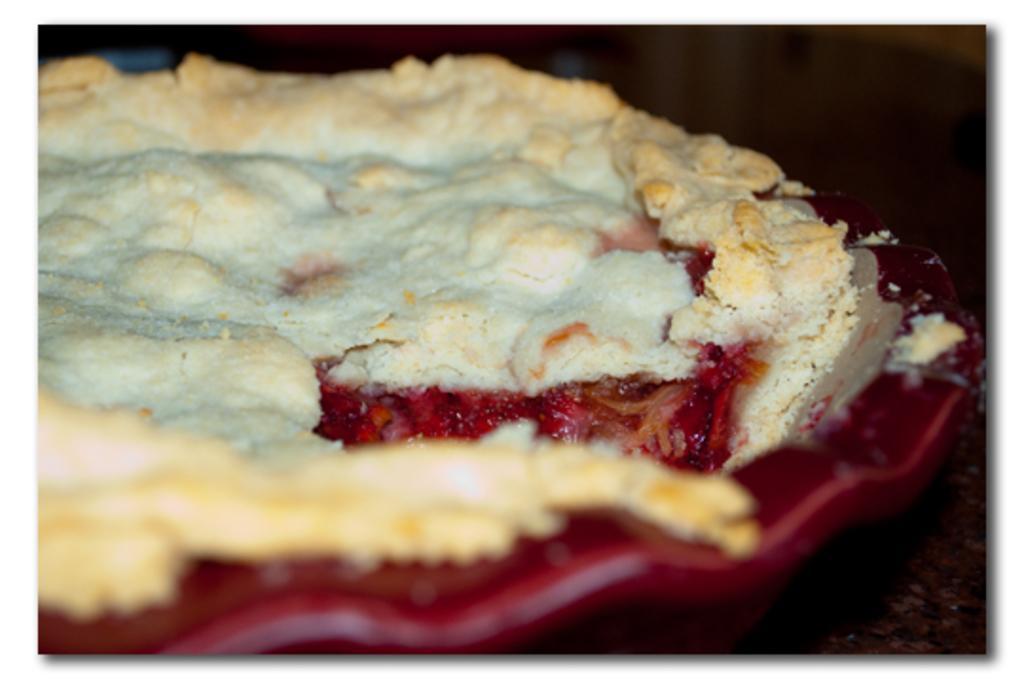Describe this image in one or two sentences. In the center of this picture we can see a red color palette containing some food item. In the background we can see some other objects. 